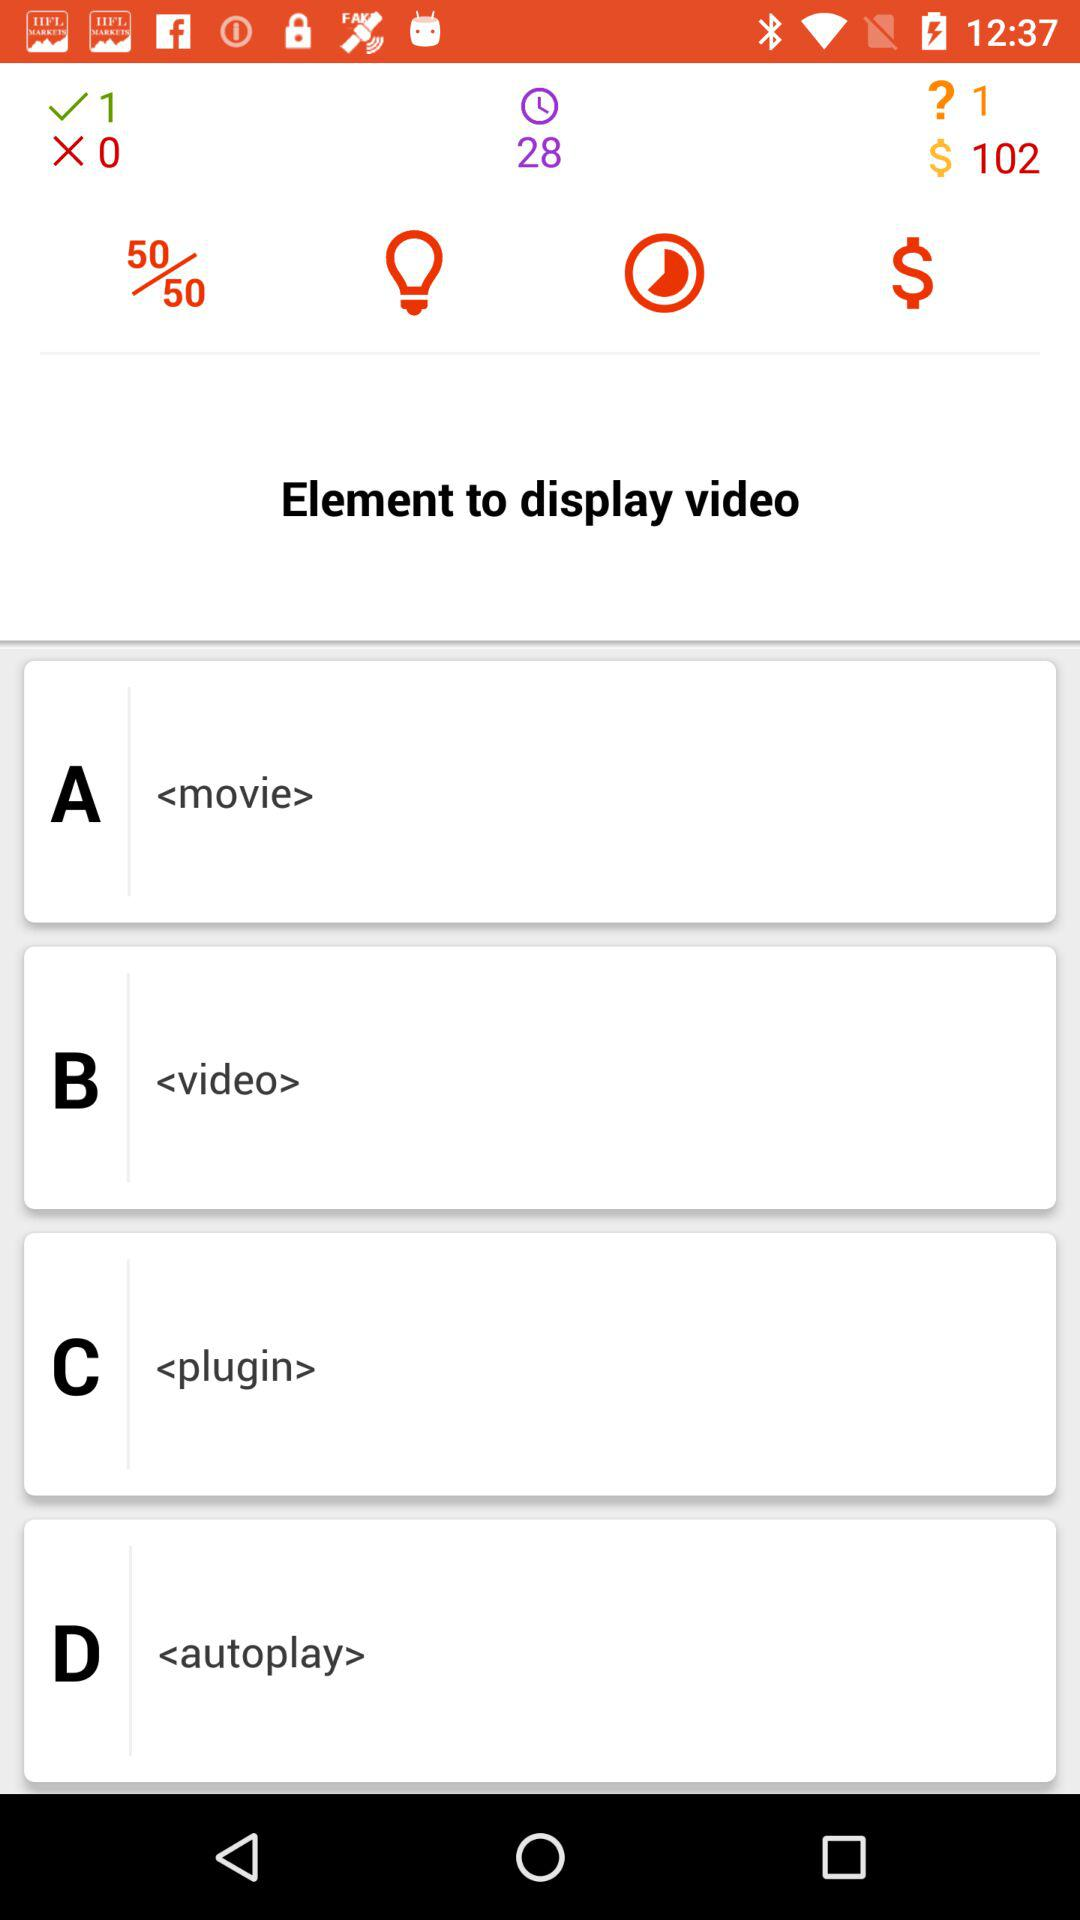How many answers are not submitted?
When the provided information is insufficient, respond with <no answer>. <no answer> 